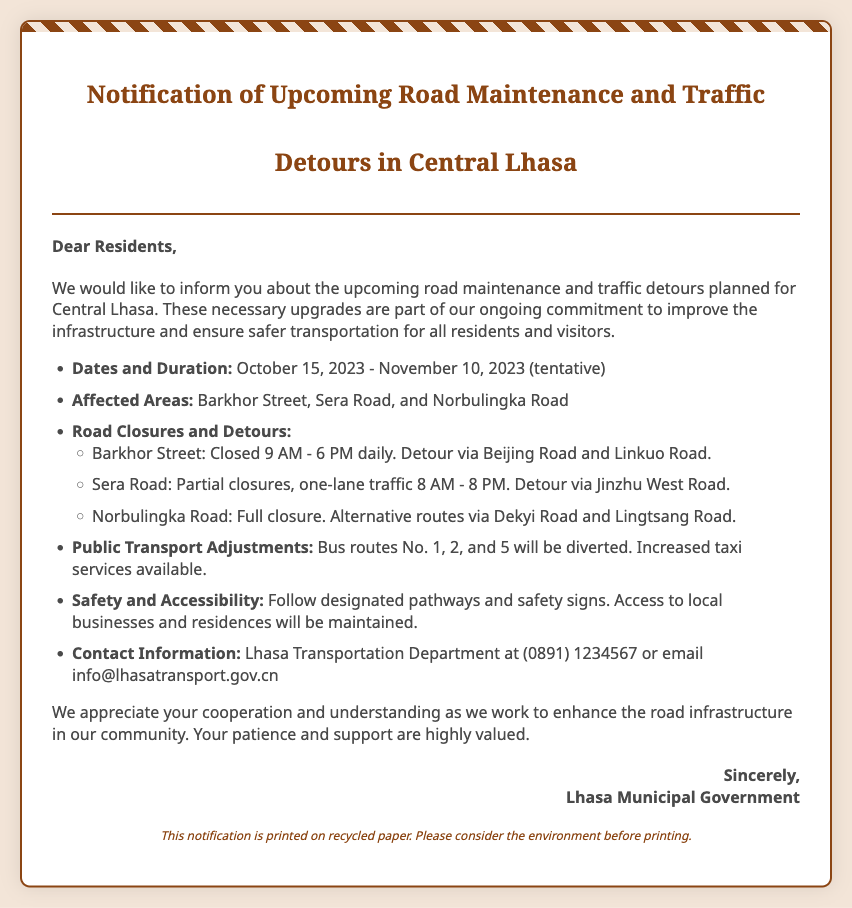What is the start date of the road maintenance? The start date is explicitly mentioned in the document as October 15, 2023.
Answer: October 15, 2023 What is the end date of the road maintenance? The end date, although tentative, is provided as November 10, 2023.
Answer: November 10, 2023 Which street will be fully closed? The document lists Norbulingka Road as the street that will be fully closed.
Answer: Norbulingka Road What are the affected areas mentioned in the document? The affected areas include Barkhor Street, Sera Road, and Norbulingka Road, as stated in the text.
Answer: Barkhor Street, Sera Road, and Norbulingka Road What are the operating hours for Barkhor Street during the maintenance? The operating hours for Barkhor Street during maintenance are specified as 9 AM to 6 PM.
Answer: 9 AM - 6 PM Which bus routes will be diverted? The bus routes mentioned as being diverted are No. 1, 2, and 5.
Answer: No. 1, 2, and 5 What should residents follow for safety during the maintenance? The document advises residents to follow designated pathways and safety signs.
Answer: Designated pathways and safety signs Who should residents contact for more information? The document provides the contact for the Lhasa Transportation Department for inquiries.
Answer: Lhasa Transportation Department What is the purpose of the road maintenance mentioned in the document? The purpose of the road maintenance is outlined as an ongoing commitment to improve infrastructure and ensure safer transportation.
Answer: Improve infrastructure and ensure safer transportation 